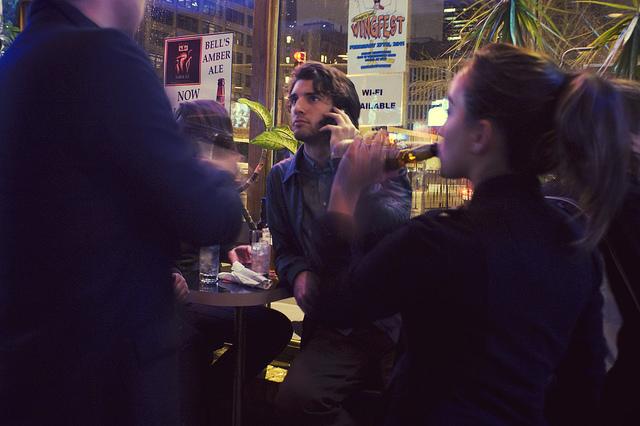What is the man doing?
Be succinct. Talking on phone. What is the ponytailed lady drinking from?
Concise answer only. Bottle. According to the sign by the man's head, what is available?
Short answer required. Wi-fi. 